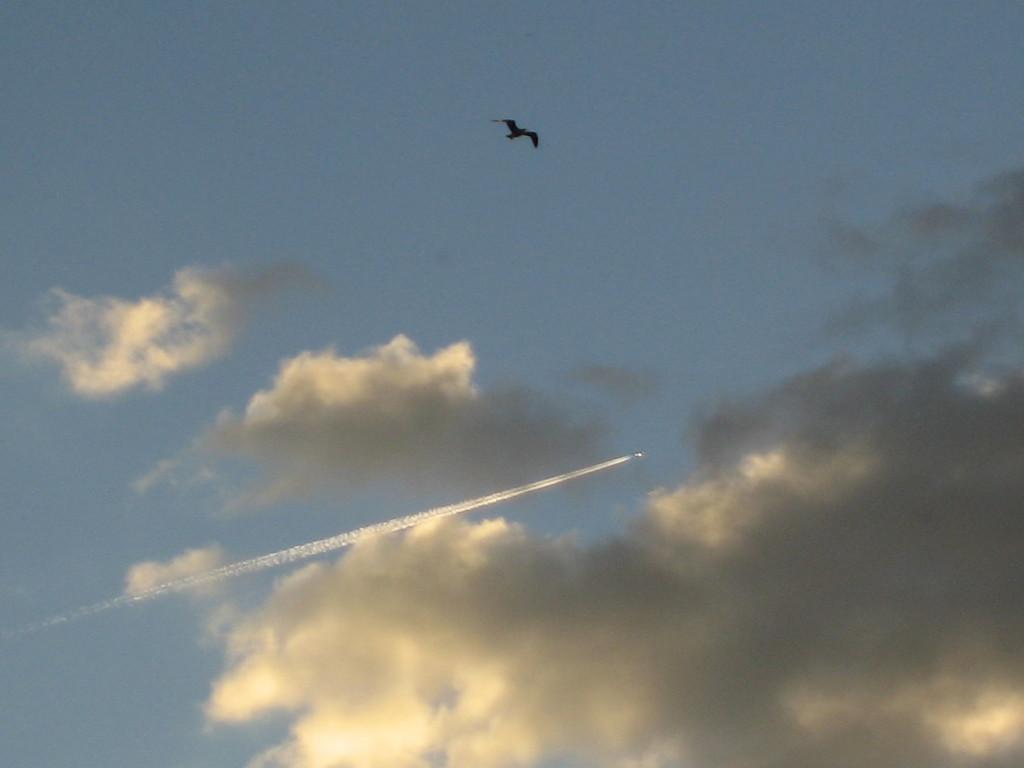What type of animal can be seen in the image? There is a bird in the image. What else is present in the sky in the image? There is an aircraft flying in the air in the image. What can be seen in the background of the image? There are clouds in the sky in the image. What type of transport does the bird use to move around in the image? Birds do not use any form of transport to move around; they fly using their wings. 